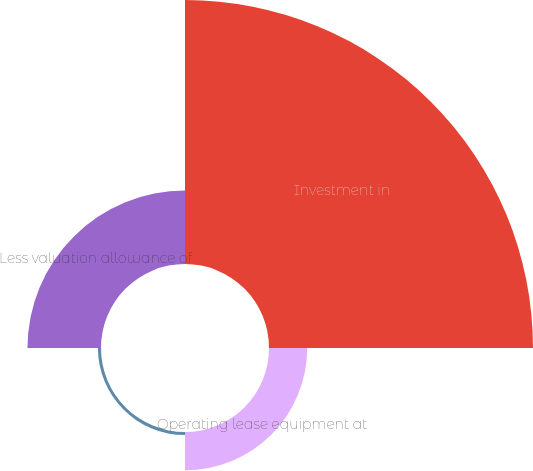Convert chart. <chart><loc_0><loc_0><loc_500><loc_500><pie_chart><fcel>Investment in<fcel>Operating lease equipment at<fcel>Notes receivable<fcel>Less valuation allowance of<nl><fcel>69.69%<fcel>10.1%<fcel>0.81%<fcel>19.4%<nl></chart> 